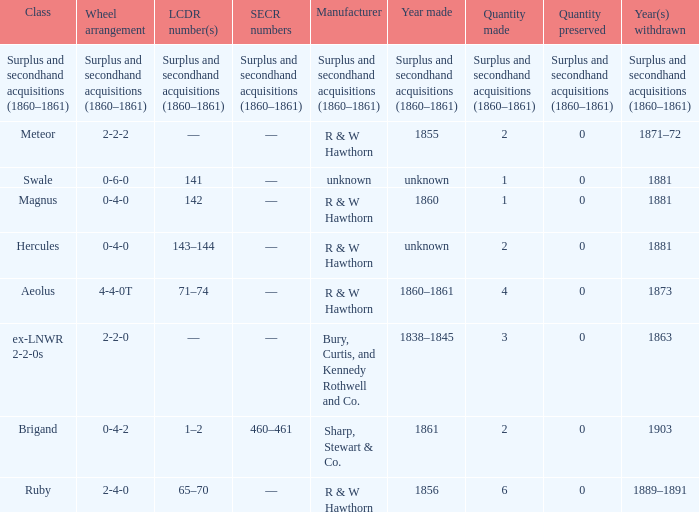What was the SECR number of the item made in 1861? 460–461. 